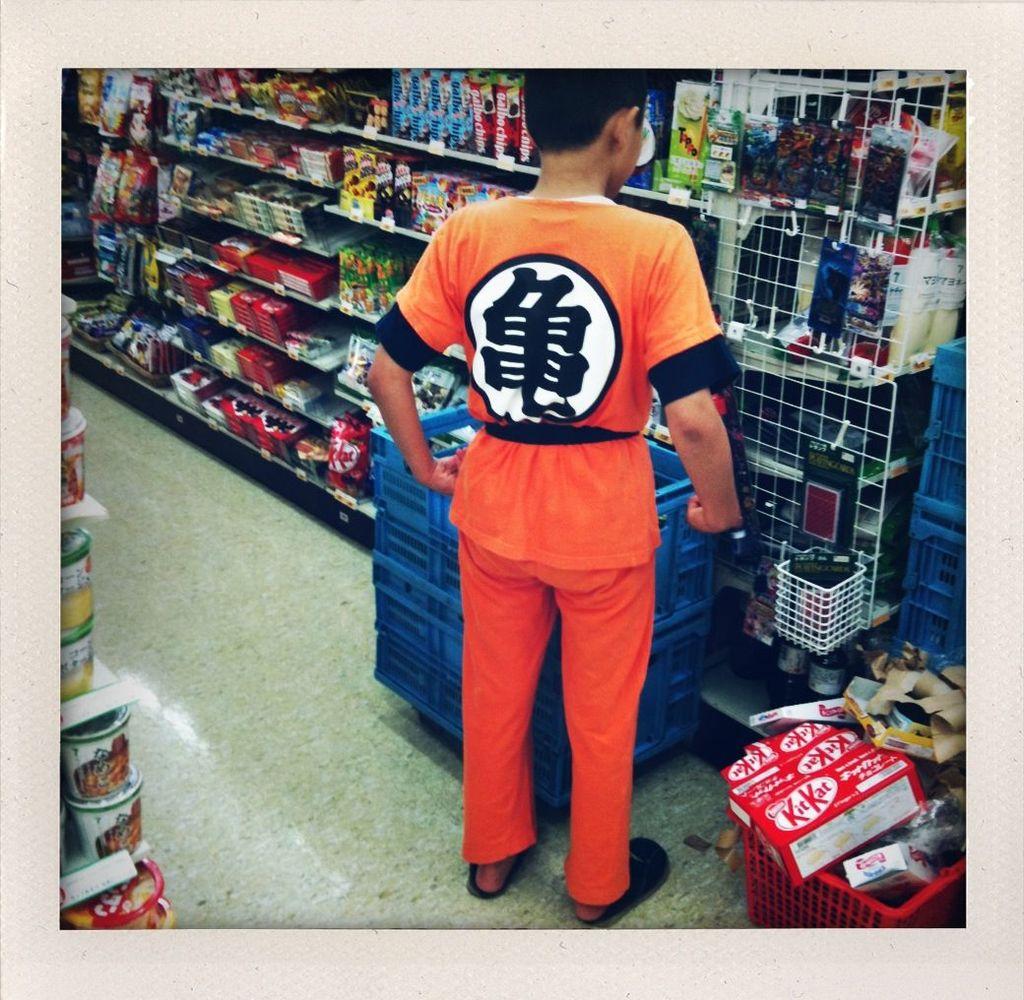What chocolate candy bar can be seen at the bottom?
Offer a terse response. Kit kat. 